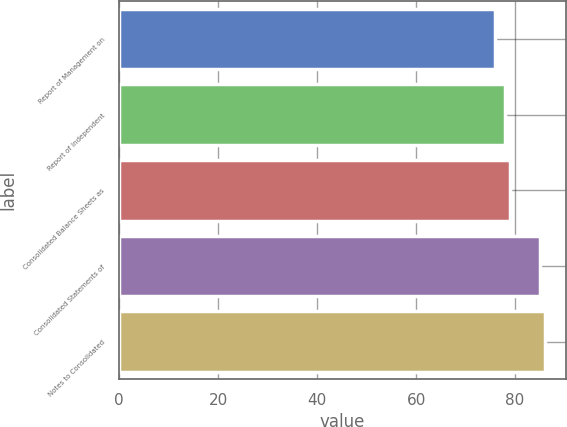Convert chart to OTSL. <chart><loc_0><loc_0><loc_500><loc_500><bar_chart><fcel>Report of Management on<fcel>Report of Independent<fcel>Consolidated Balance Sheets as<fcel>Consolidated Statements of<fcel>Notes to Consolidated<nl><fcel>76<fcel>78<fcel>79<fcel>85<fcel>86<nl></chart> 